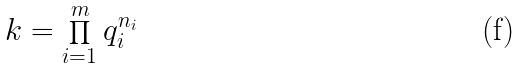Convert formula to latex. <formula><loc_0><loc_0><loc_500><loc_500>k = \prod _ { i = 1 } ^ { m } q _ { i } ^ { n _ { i } }</formula> 